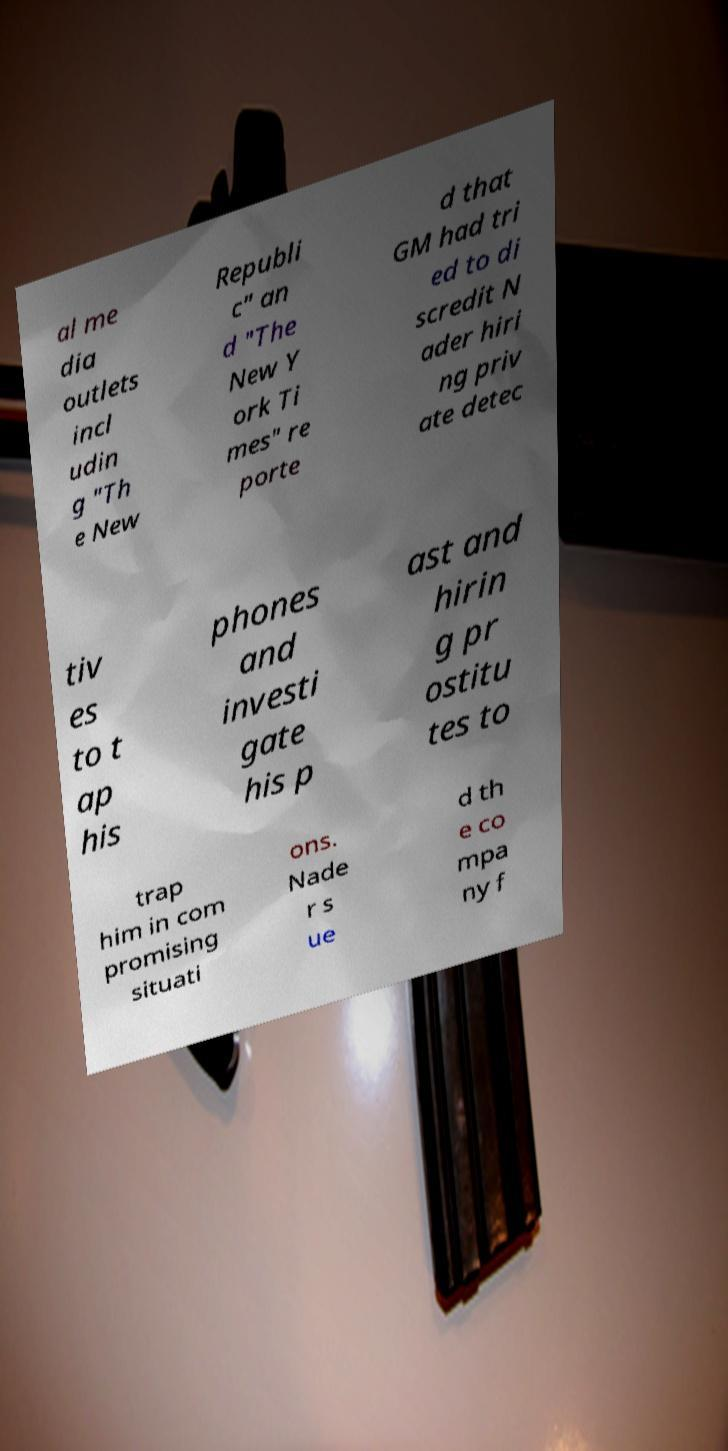What messages or text are displayed in this image? I need them in a readable, typed format. al me dia outlets incl udin g "Th e New Republi c" an d "The New Y ork Ti mes" re porte d that GM had tri ed to di scredit N ader hiri ng priv ate detec tiv es to t ap his phones and investi gate his p ast and hirin g pr ostitu tes to trap him in com promising situati ons. Nade r s ue d th e co mpa ny f 